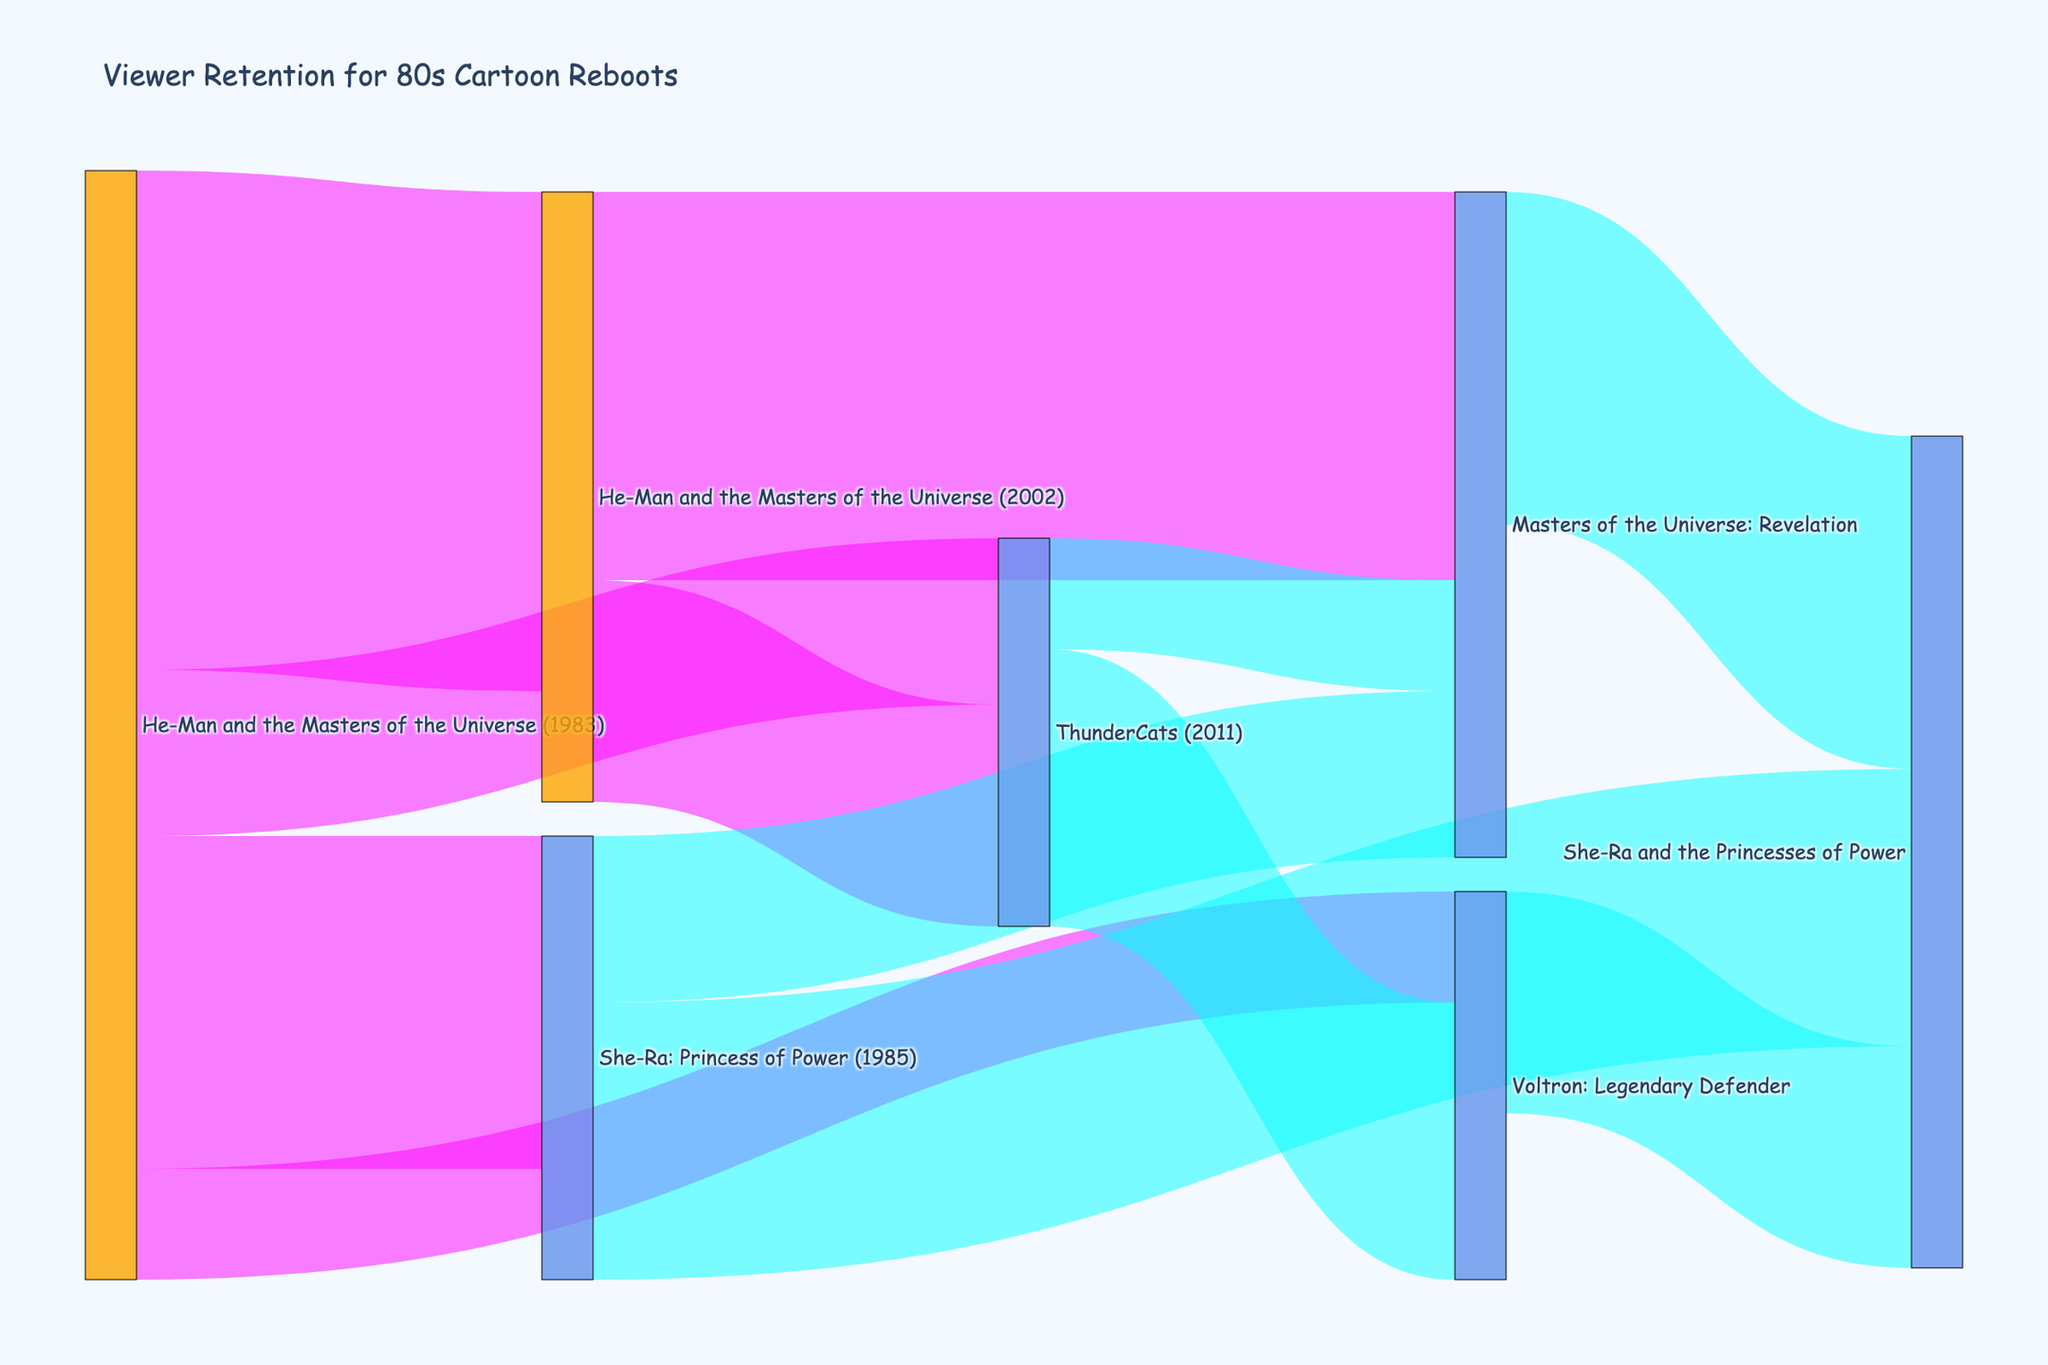How many viewers migrated from He-Man and the Masters of the Universe (1983) to She-Ra: Princess of Power (1985)? From the Sankey diagram, we can see a connection line labeled with the value representing migration from He-Man and the Masters of the Universe (1983) to She-Ra: Princess of Power (1985). The value associated with this line is 30.
Answer: 30 Which show received the most viewers from He-Man and the Masters of the Universe (1983)? To determine this, we need to compare values linked to He-Man and the Masters of the Universe (1983). The values are: He-Man and the Masters of the Universe (2002) - 45, She-Ra: Princess of Power (1985) - 30, ThunderCats (2011) - 15, Voltron: Legendary Defender - 10. The highest value is 45.
Answer: He-Man and the Masters of the Universe (2002) How many viewers migrated from ThunderCats (2011) in total? Look at all the connections from ThunderCats (2011). ThunderCats viewers migrated to Voltron: Legendary Defender (25) and Masters of the Universe: Revelation (10). Summing these values gives 25 + 10.
Answer: 35 Which show has the thickest band coming into it, indicating the highest retention rate? The thickness of bands in a Sankey diagram represents the value of flow. Comparing the target values, She-Ra and the Princesses of Power has bands with values 25 and 20 summing to 45, while Masters of the Universe: Revelation has bands with values 35 and 15 summing to 50. The thickest single band is into Masters of the Universe: Revelation with value 35.
Answer: Masters of the Universe: Revelation How many viewers stayed within the He-Man series (including its reboots)? Look at migrations staying within He-Man’s universe: He-Man and the Masters of the Universe (1983) to He-Man and the Masters of the Universe (2002) - 45, He-Man and the Masters of the Universe (2002) to Masters of the Universe: Revelation - 35. Summing them up: 45 + 35.
Answer: 80 Which show received viewers from Voltron: Legendary Defender? Look at the target nodes with connections from Voltron: Legendary Defender. There is a flow from Voltron: Legendary Defender to She-Ra and the Princesses of Power with a value of 20.
Answer: She-Ra and the Princesses of Power How many viewers ended up watching Masters of the Universe: Revelation? Sum the values flowing into Masters of the Universe: Revelation. From He-Man and the Masters of the Universe (2002) - 35, from She-Ra: Princess of Power (1985) - 15, and from ThunderCats (2011) - 10. Therefore, 35 + 15 + 10.
Answer: 60 